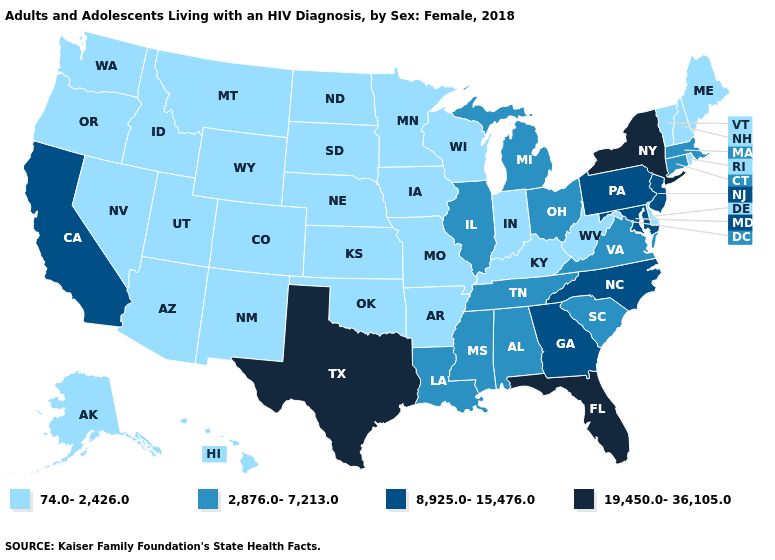Does the map have missing data?
Keep it brief. No. Which states hav the highest value in the South?
Short answer required. Florida, Texas. Name the states that have a value in the range 74.0-2,426.0?
Write a very short answer. Alaska, Arizona, Arkansas, Colorado, Delaware, Hawaii, Idaho, Indiana, Iowa, Kansas, Kentucky, Maine, Minnesota, Missouri, Montana, Nebraska, Nevada, New Hampshire, New Mexico, North Dakota, Oklahoma, Oregon, Rhode Island, South Dakota, Utah, Vermont, Washington, West Virginia, Wisconsin, Wyoming. What is the value of Texas?
Keep it brief. 19,450.0-36,105.0. Is the legend a continuous bar?
Short answer required. No. Which states hav the highest value in the Northeast?
Write a very short answer. New York. What is the value of Indiana?
Give a very brief answer. 74.0-2,426.0. Name the states that have a value in the range 2,876.0-7,213.0?
Be succinct. Alabama, Connecticut, Illinois, Louisiana, Massachusetts, Michigan, Mississippi, Ohio, South Carolina, Tennessee, Virginia. What is the lowest value in the South?
Concise answer only. 74.0-2,426.0. Does Rhode Island have a lower value than Massachusetts?
Concise answer only. Yes. What is the value of Kansas?
Answer briefly. 74.0-2,426.0. What is the value of Georgia?
Write a very short answer. 8,925.0-15,476.0. Does Alabama have the lowest value in the USA?
Write a very short answer. No. What is the value of Virginia?
Answer briefly. 2,876.0-7,213.0. What is the value of California?
Be succinct. 8,925.0-15,476.0. 